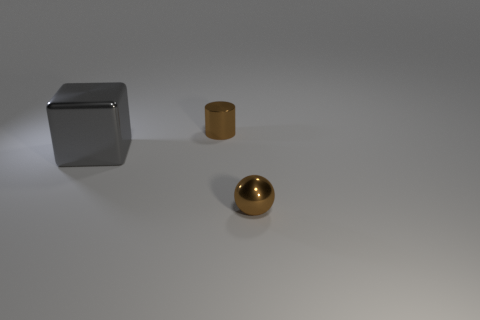Add 1 cylinders. How many objects exist? 4 Subtract all blocks. How many objects are left? 2 Add 2 tiny brown matte cylinders. How many tiny brown matte cylinders exist? 2 Subtract 1 brown spheres. How many objects are left? 2 Subtract all brown shiny cylinders. Subtract all small brown metal cylinders. How many objects are left? 1 Add 2 tiny brown metal cylinders. How many tiny brown metal cylinders are left? 3 